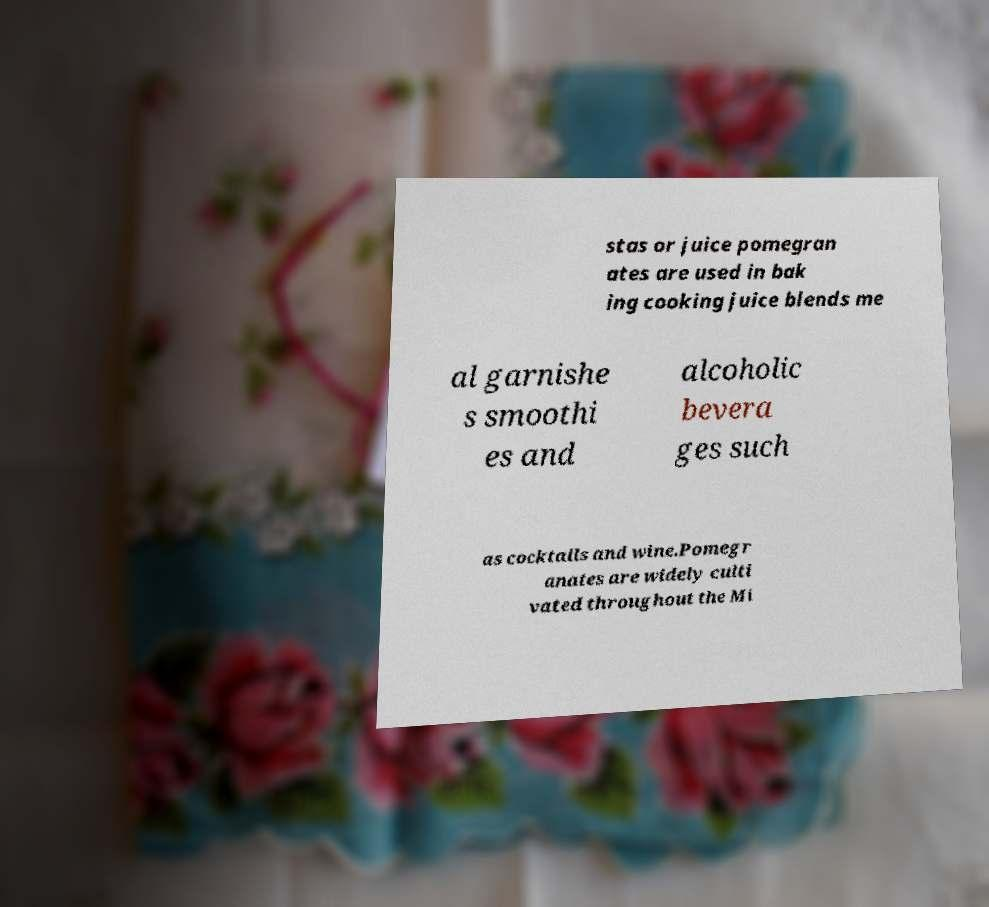Please read and relay the text visible in this image. What does it say? stas or juice pomegran ates are used in bak ing cooking juice blends me al garnishe s smoothi es and alcoholic bevera ges such as cocktails and wine.Pomegr anates are widely culti vated throughout the Mi 